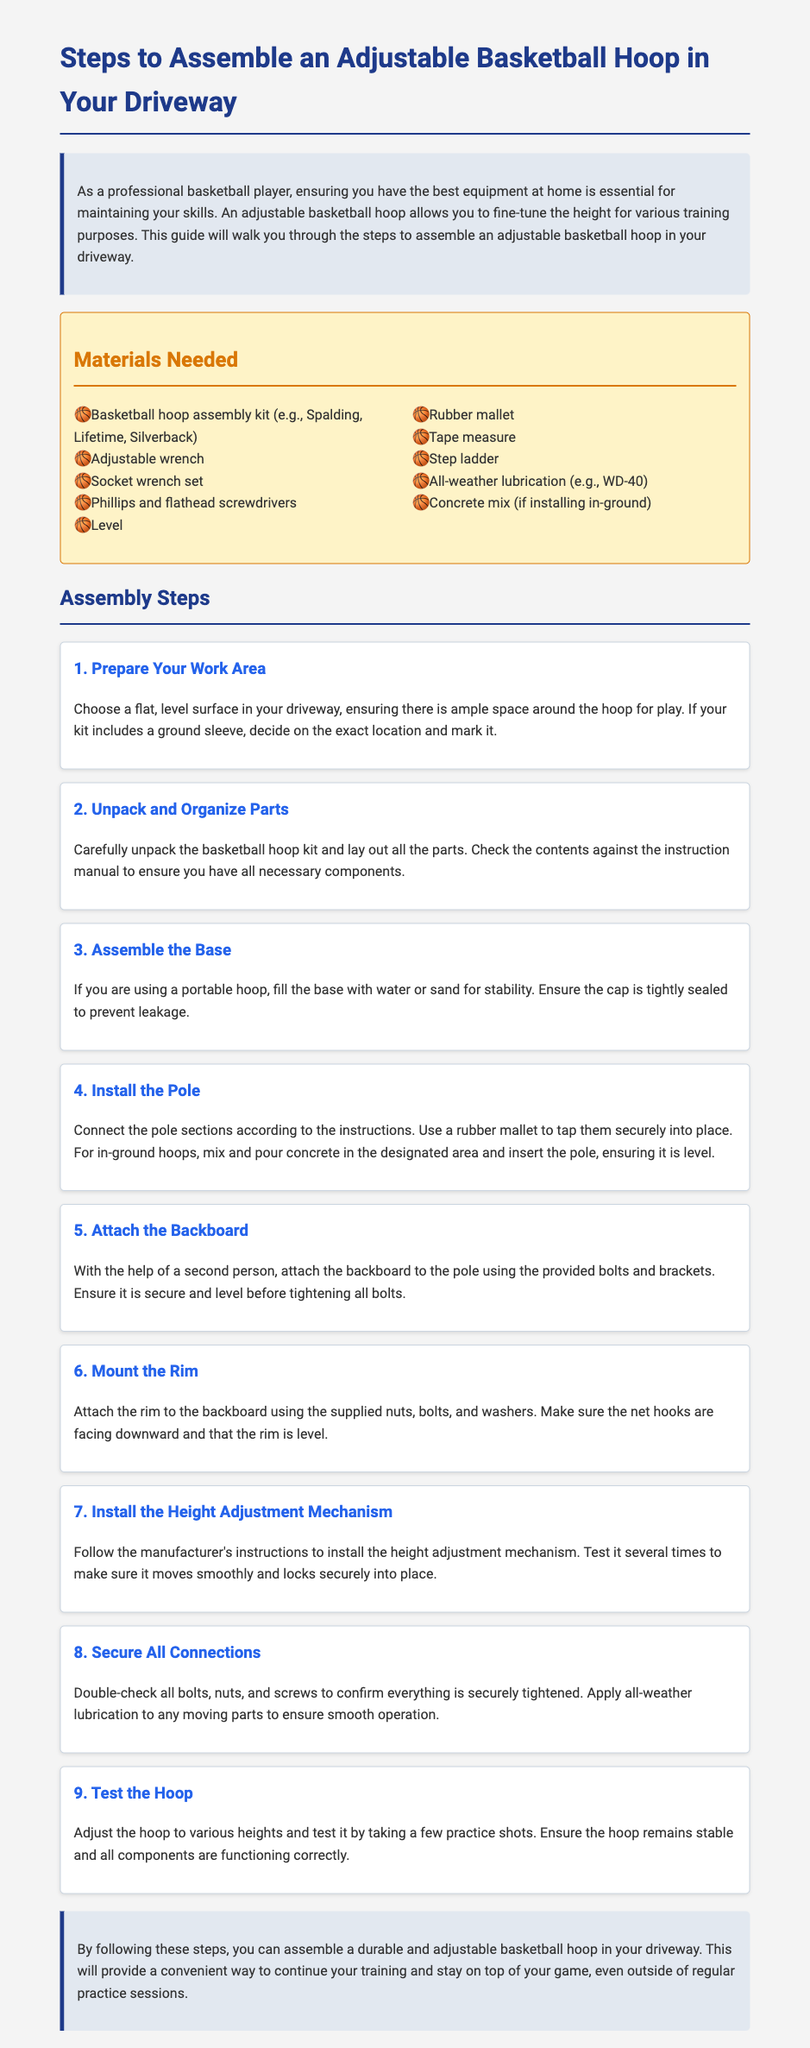What is the first step in the assembly process? The first step is to prepare your work area by choosing a flat, level surface in your driveway.
Answer: Prepare Your Work Area What tool is required for tightening bolts? The document lists that you need an adjustable wrench for assembling the basketball hoop, which is used for tightening bolts.
Answer: Adjustable wrench How many steps are there in total for assembly? The document outlines a total of nine steps for assembling an adjustable basketball hoop.
Answer: Nine What should you do if using a portable hoop? If using a portable hoop, you should fill the base with water or sand for stability.
Answer: Fill the base with water or sand What is necessary to install the height adjustment mechanism? You must follow the manufacturer's instructions to install the height adjustment mechanism properly.
Answer: Manufacturer's instructions Why is all-weather lubrication needed? All-weather lubrication is applied to any moving parts to ensure smooth operation.
Answer: Smooth operation What should you do to test the hoop after assembly? After assembly, you should adjust the hoop to various heights and take practice shots to ensure it is functioning correctly.
Answer: Take practice shots What is the purpose of the backboard? The backboard is attached to the pole to provide a surface for rebounds when shooting the basketball.
Answer: Surface for rebounds 